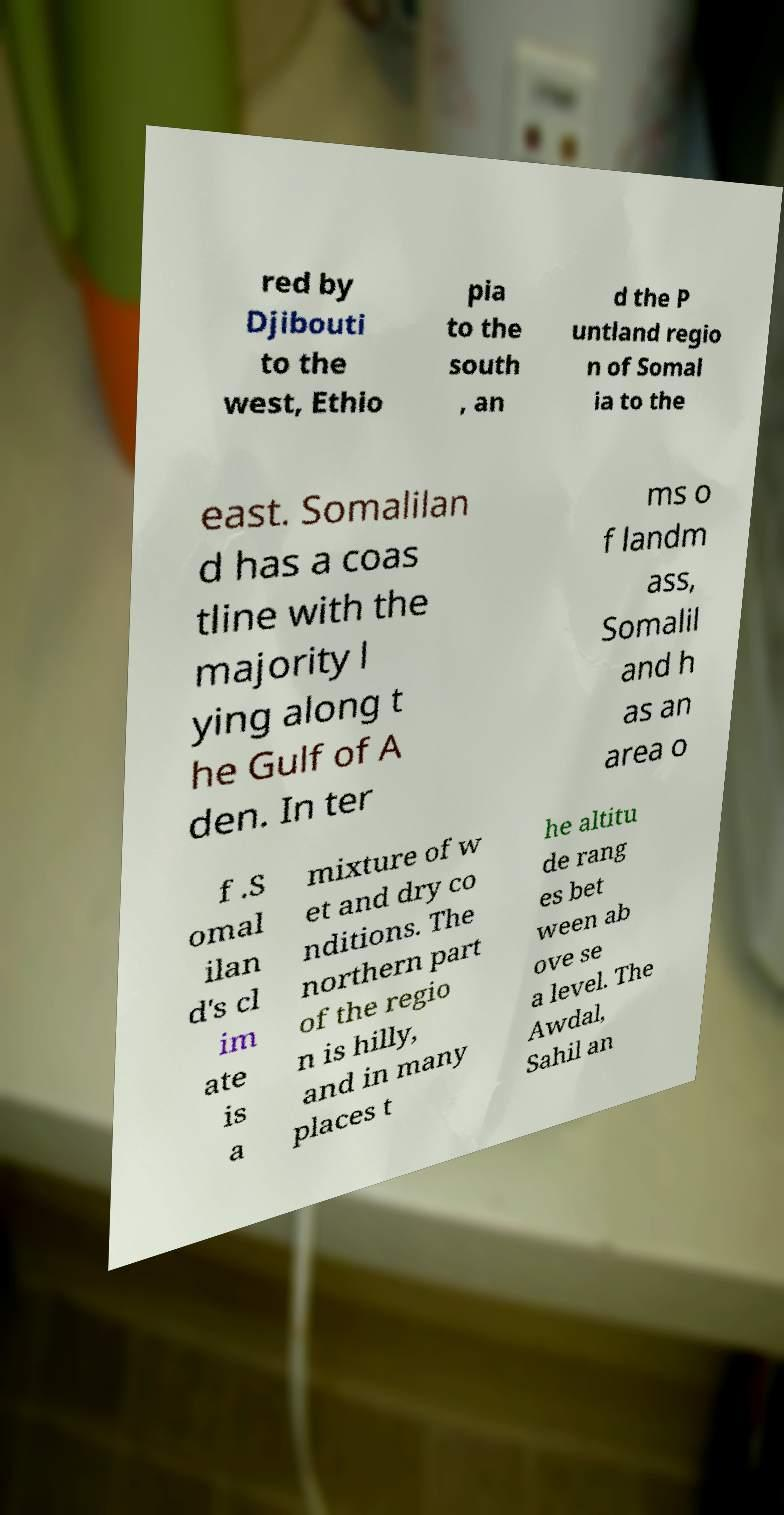For documentation purposes, I need the text within this image transcribed. Could you provide that? red by Djibouti to the west, Ethio pia to the south , an d the P untland regio n of Somal ia to the east. Somalilan d has a coas tline with the majority l ying along t he Gulf of A den. In ter ms o f landm ass, Somalil and h as an area o f .S omal ilan d's cl im ate is a mixture of w et and dry co nditions. The northern part of the regio n is hilly, and in many places t he altitu de rang es bet ween ab ove se a level. The Awdal, Sahil an 